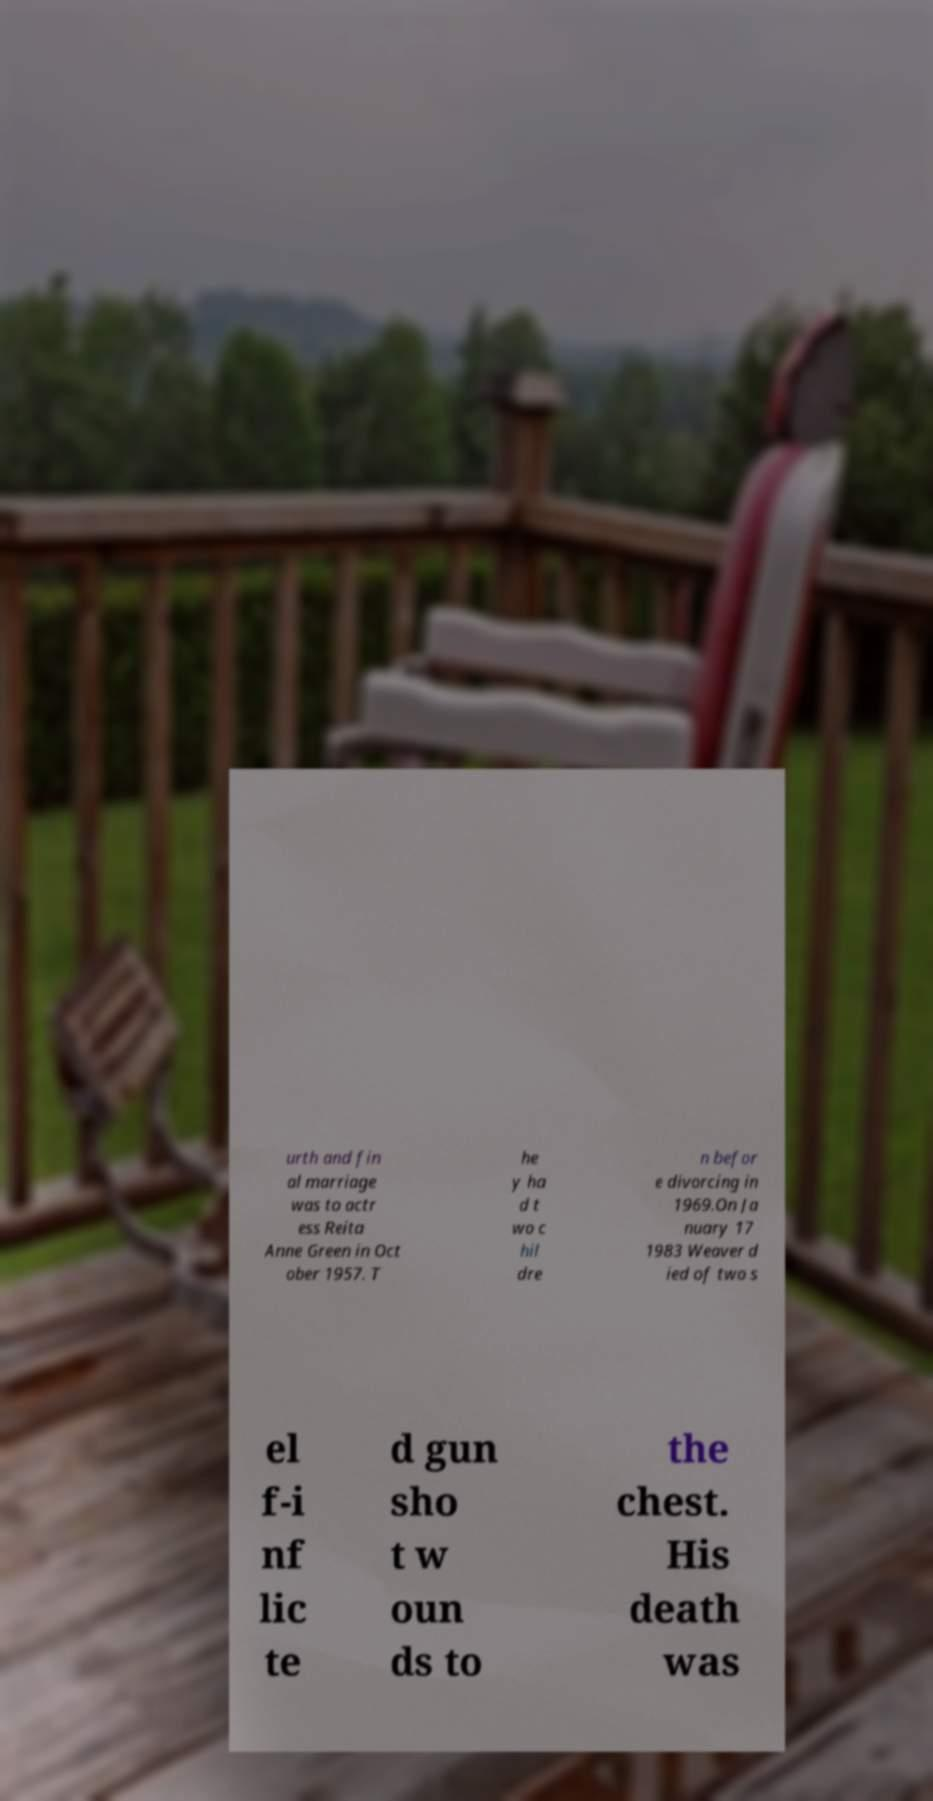Please read and relay the text visible in this image. What does it say? urth and fin al marriage was to actr ess Reita Anne Green in Oct ober 1957. T he y ha d t wo c hil dre n befor e divorcing in 1969.On Ja nuary 17 1983 Weaver d ied of two s el f-i nf lic te d gun sho t w oun ds to the chest. His death was 